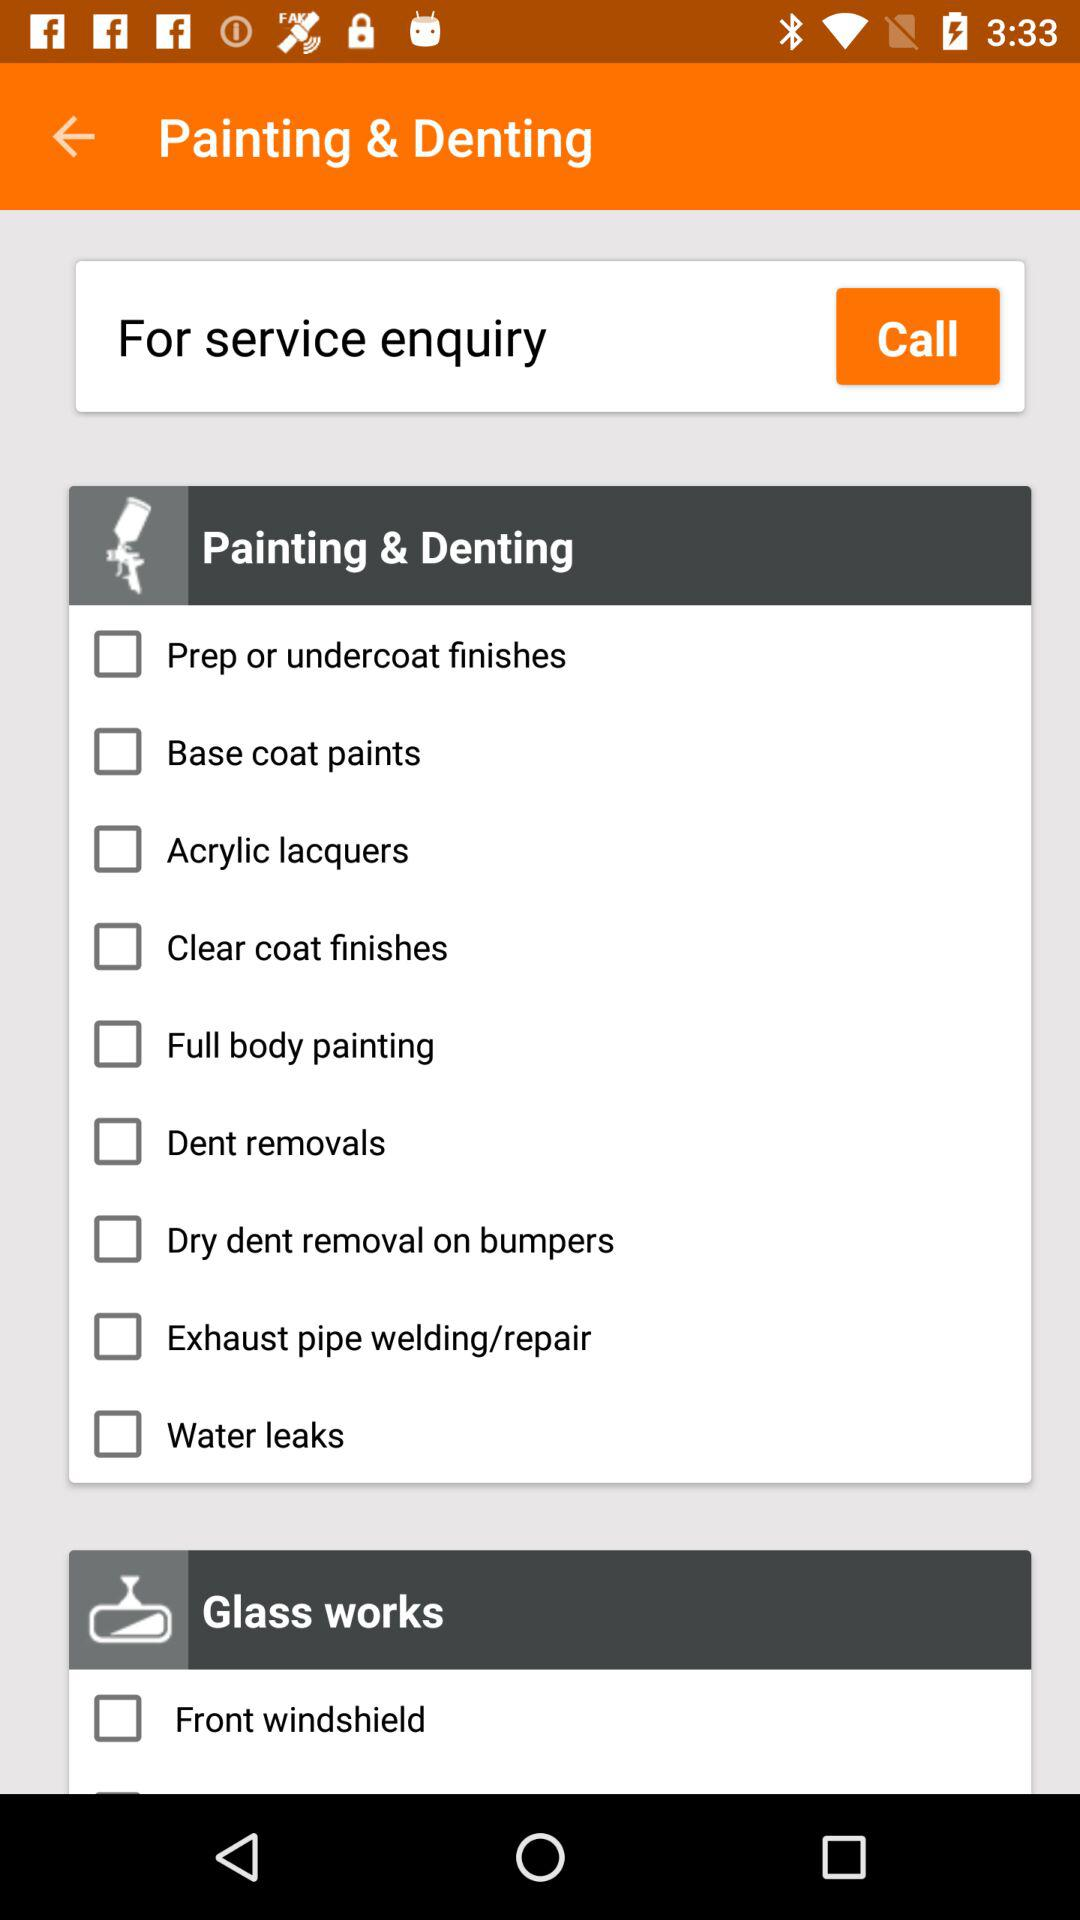How many checkbox items are in the 'Glass Works' section?
Answer the question using a single word or phrase. 1 